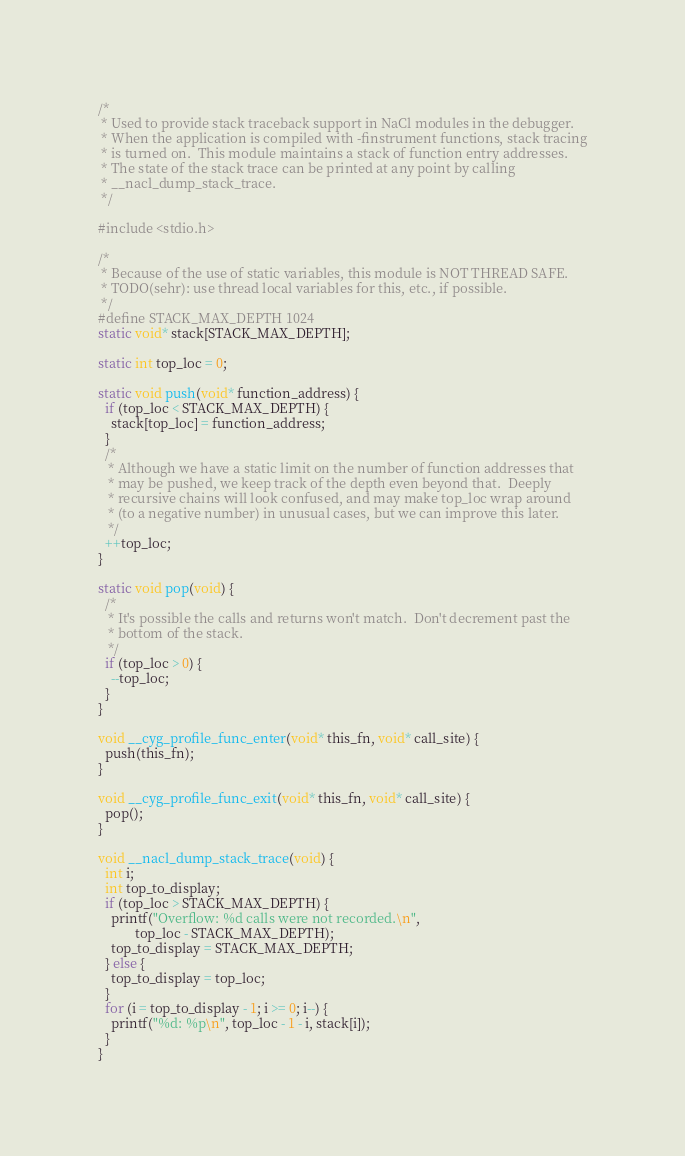Convert code to text. <code><loc_0><loc_0><loc_500><loc_500><_C_>/*
 * Used to provide stack traceback support in NaCl modules in the debugger.
 * When the application is compiled with -finstrument functions, stack tracing
 * is turned on.  This module maintains a stack of function entry addresses.
 * The state of the stack trace can be printed at any point by calling
 * __nacl_dump_stack_trace.
 */

#include <stdio.h>

/*
 * Because of the use of static variables, this module is NOT THREAD SAFE.
 * TODO(sehr): use thread local variables for this, etc., if possible.
 */
#define STACK_MAX_DEPTH 1024
static void* stack[STACK_MAX_DEPTH];

static int top_loc = 0;

static void push(void* function_address) {
  if (top_loc < STACK_MAX_DEPTH) {
    stack[top_loc] = function_address;
  }
  /*
   * Although we have a static limit on the number of function addresses that
   * may be pushed, we keep track of the depth even beyond that.  Deeply
   * recursive chains will look confused, and may make top_loc wrap around
   * (to a negative number) in unusual cases, but we can improve this later.
   */
  ++top_loc;
}

static void pop(void) {
  /*
   * It's possible the calls and returns won't match.  Don't decrement past the
   * bottom of the stack.
   */
  if (top_loc > 0) {
    --top_loc;
  }
}

void __cyg_profile_func_enter(void* this_fn, void* call_site) {
  push(this_fn);
}

void __cyg_profile_func_exit(void* this_fn, void* call_site) {
  pop();
}

void __nacl_dump_stack_trace(void) {
  int i;
  int top_to_display;
  if (top_loc > STACK_MAX_DEPTH) {
    printf("Overflow: %d calls were not recorded.\n",
           top_loc - STACK_MAX_DEPTH);
    top_to_display = STACK_MAX_DEPTH;
  } else {
    top_to_display = top_loc;
  }
  for (i = top_to_display - 1; i >= 0; i--) {
    printf("%d: %p\n", top_loc - 1 - i, stack[i]);
  }
}
</code> 